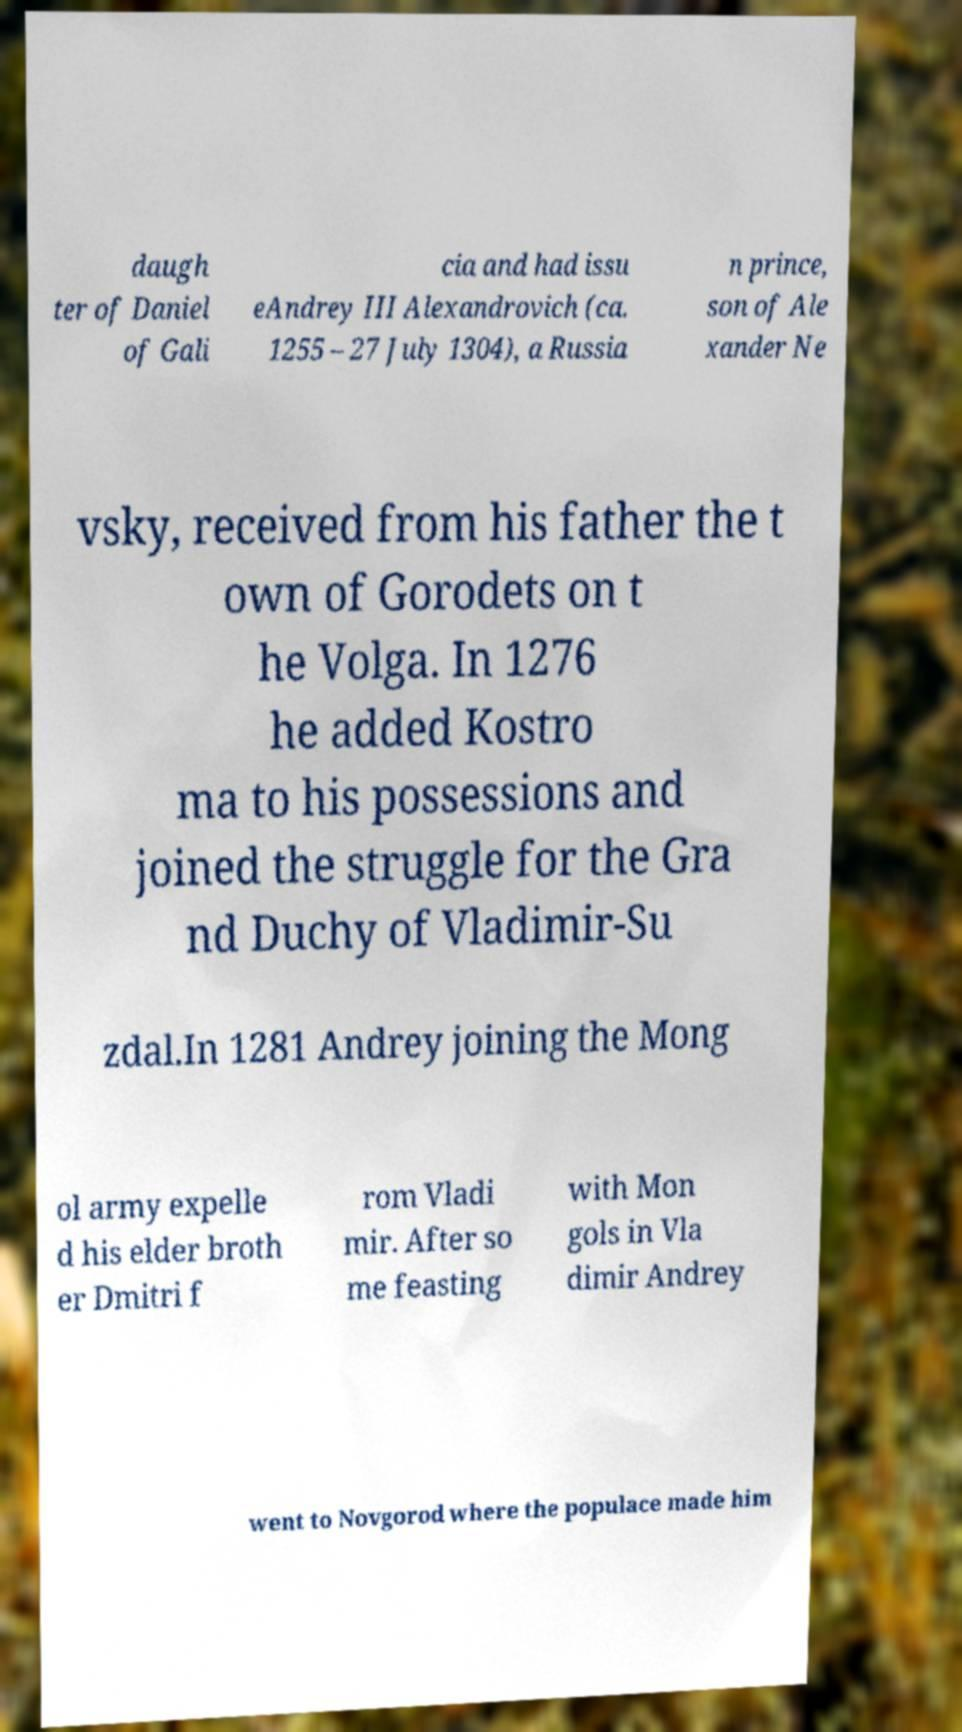There's text embedded in this image that I need extracted. Can you transcribe it verbatim? daugh ter of Daniel of Gali cia and had issu eAndrey III Alexandrovich (ca. 1255 – 27 July 1304), a Russia n prince, son of Ale xander Ne vsky, received from his father the t own of Gorodets on t he Volga. In 1276 he added Kostro ma to his possessions and joined the struggle for the Gra nd Duchy of Vladimir-Su zdal.In 1281 Andrey joining the Mong ol army expelle d his elder broth er Dmitri f rom Vladi mir. After so me feasting with Mon gols in Vla dimir Andrey went to Novgorod where the populace made him 